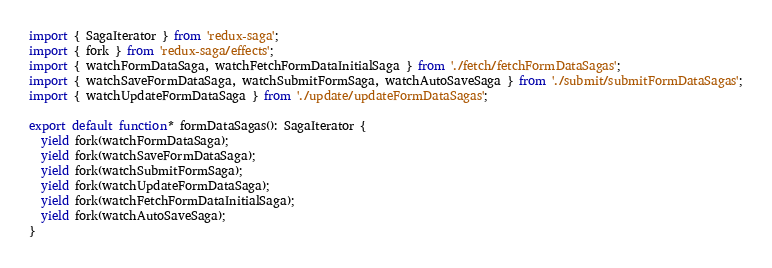<code> <loc_0><loc_0><loc_500><loc_500><_TypeScript_>import { SagaIterator } from 'redux-saga';
import { fork } from 'redux-saga/effects';
import { watchFormDataSaga, watchFetchFormDataInitialSaga } from './fetch/fetchFormDataSagas';
import { watchSaveFormDataSaga, watchSubmitFormSaga, watchAutoSaveSaga } from './submit/submitFormDataSagas';
import { watchUpdateFormDataSaga } from './update/updateFormDataSagas';

export default function* formDataSagas(): SagaIterator {
  yield fork(watchFormDataSaga);
  yield fork(watchSaveFormDataSaga);
  yield fork(watchSubmitFormSaga);
  yield fork(watchUpdateFormDataSaga);
  yield fork(watchFetchFormDataInitialSaga);
  yield fork(watchAutoSaveSaga);
}
</code> 